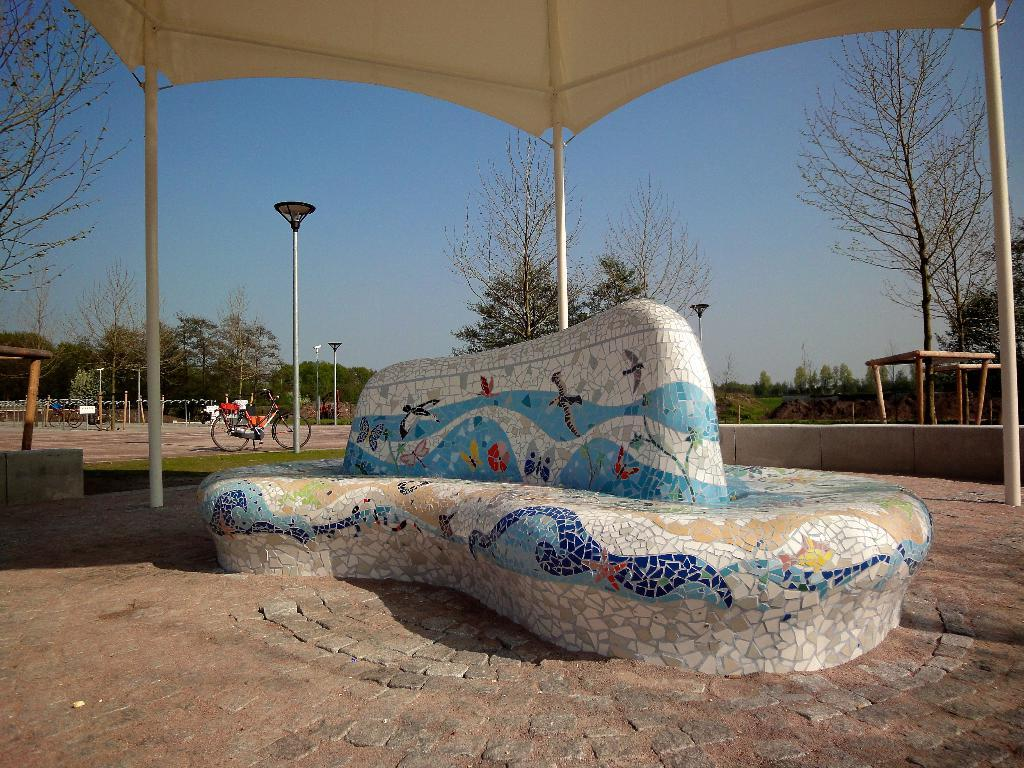What is hanging on the wall in the image? There is a painting on the wall in the image. What can be seen in the background of the image? In the background of the image, there are light poles, trees, a bicycle, an open-shed, and a blue sky. Can you describe the open-shed in the image? The open-shed is a structure with an open roof and walls, providing shelter or storage space. What type of science experiment is being conducted in the image? There is no science experiment present in the image; it features a painting on the wall and various elements in the background. 